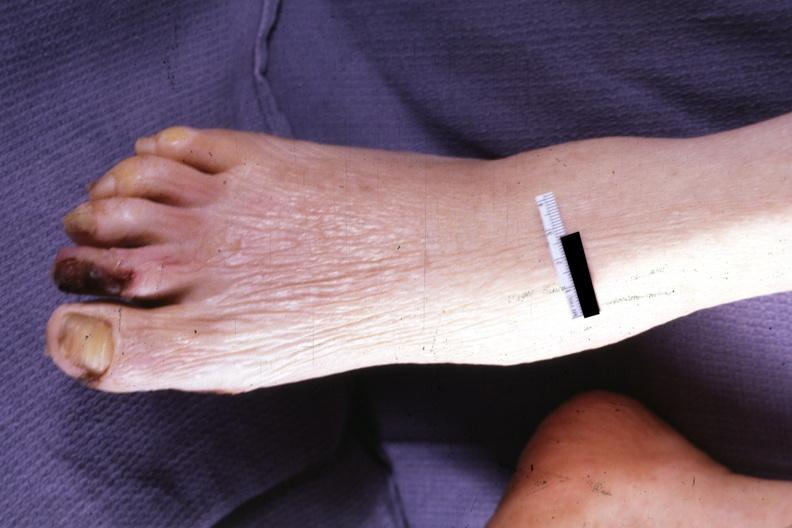s foot present?
Answer the question using a single word or phrase. Yes 